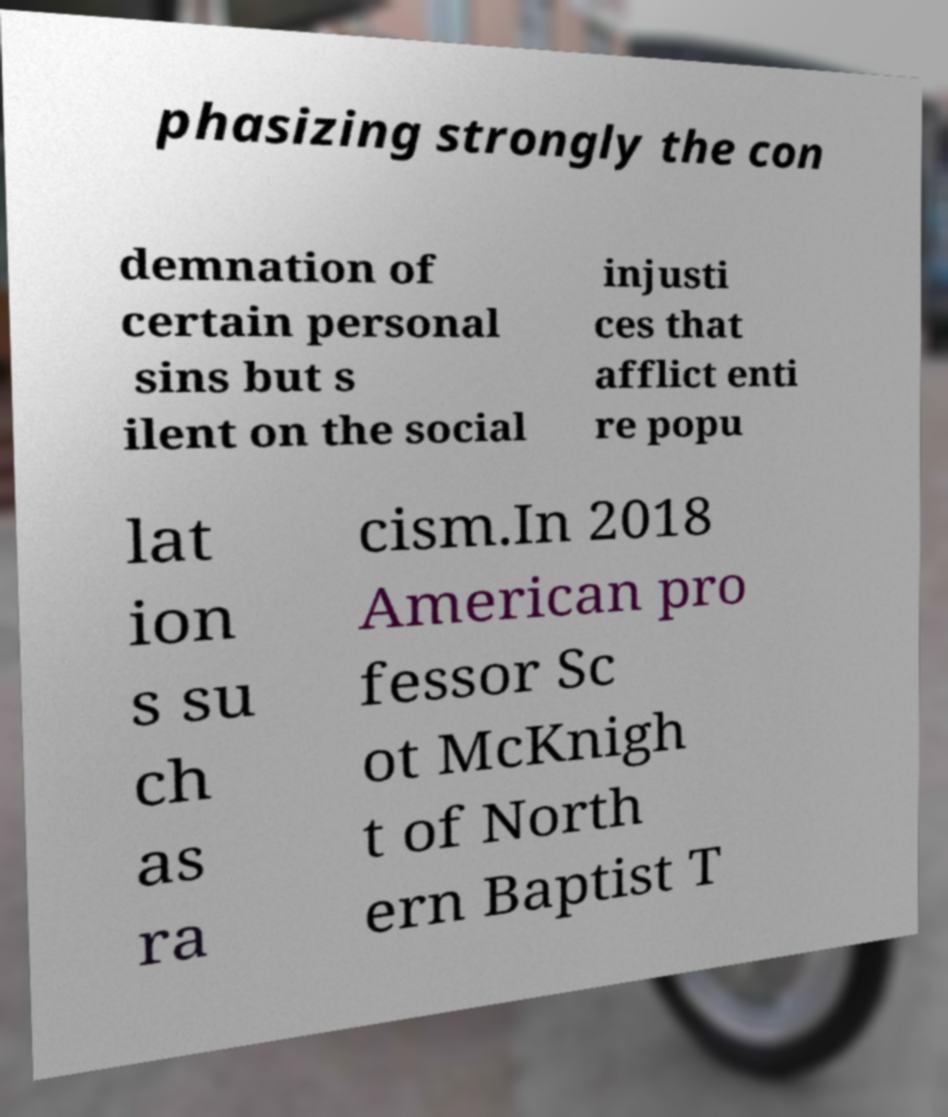Can you read and provide the text displayed in the image?This photo seems to have some interesting text. Can you extract and type it out for me? phasizing strongly the con demnation of certain personal sins but s ilent on the social injusti ces that afflict enti re popu lat ion s su ch as ra cism.In 2018 American pro fessor Sc ot McKnigh t of North ern Baptist T 